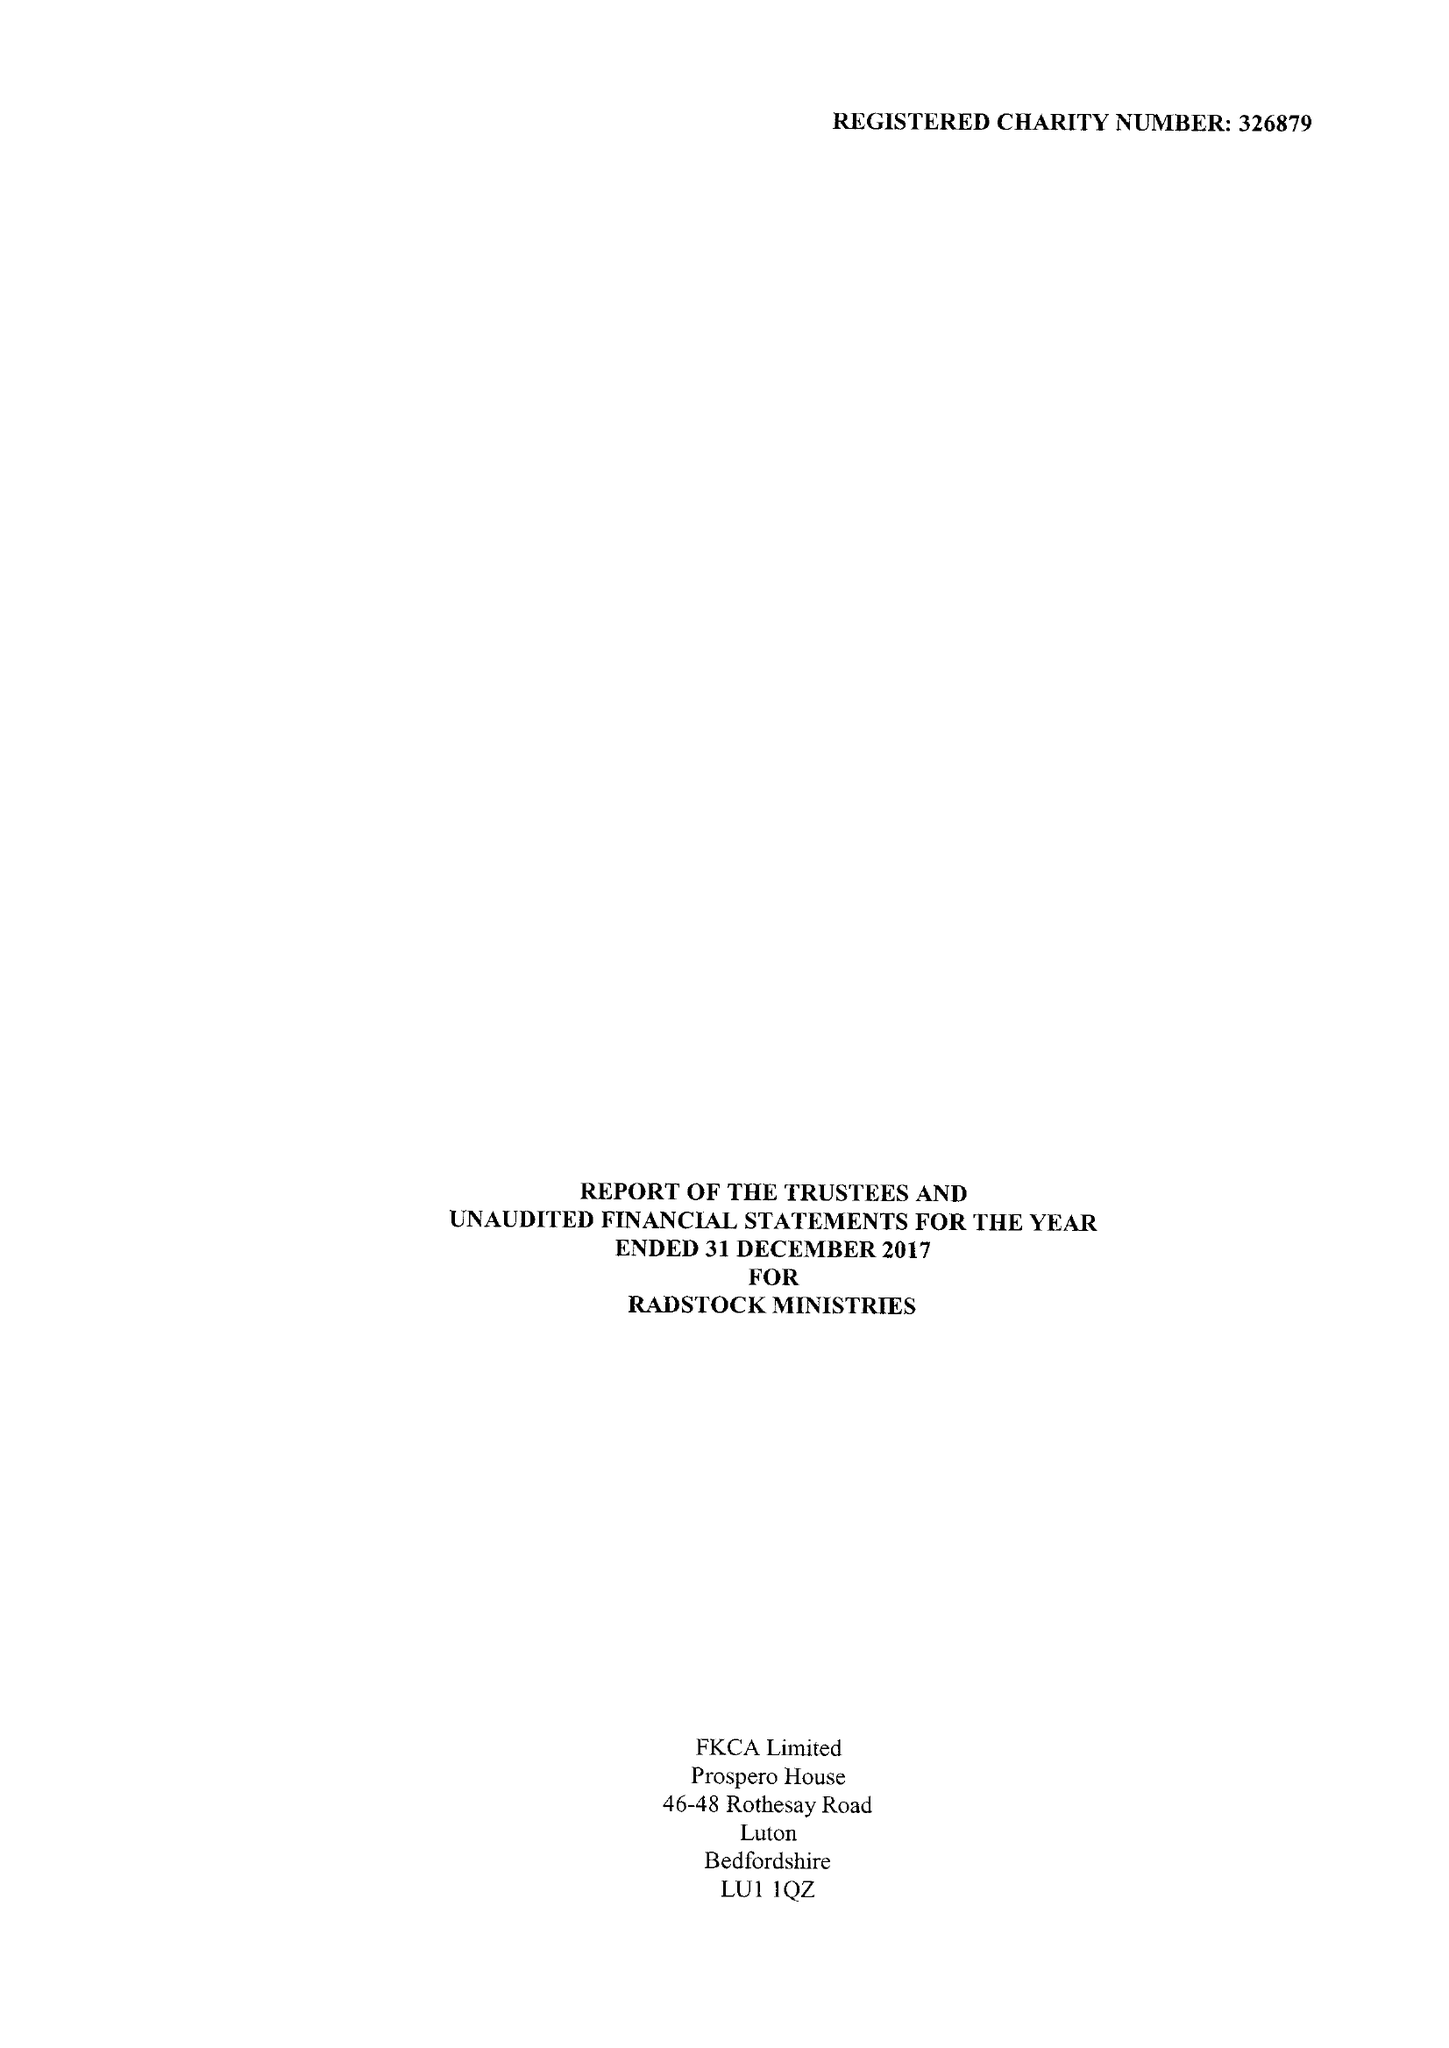What is the value for the charity_name?
Answer the question using a single word or phrase. Radstock Ministries 